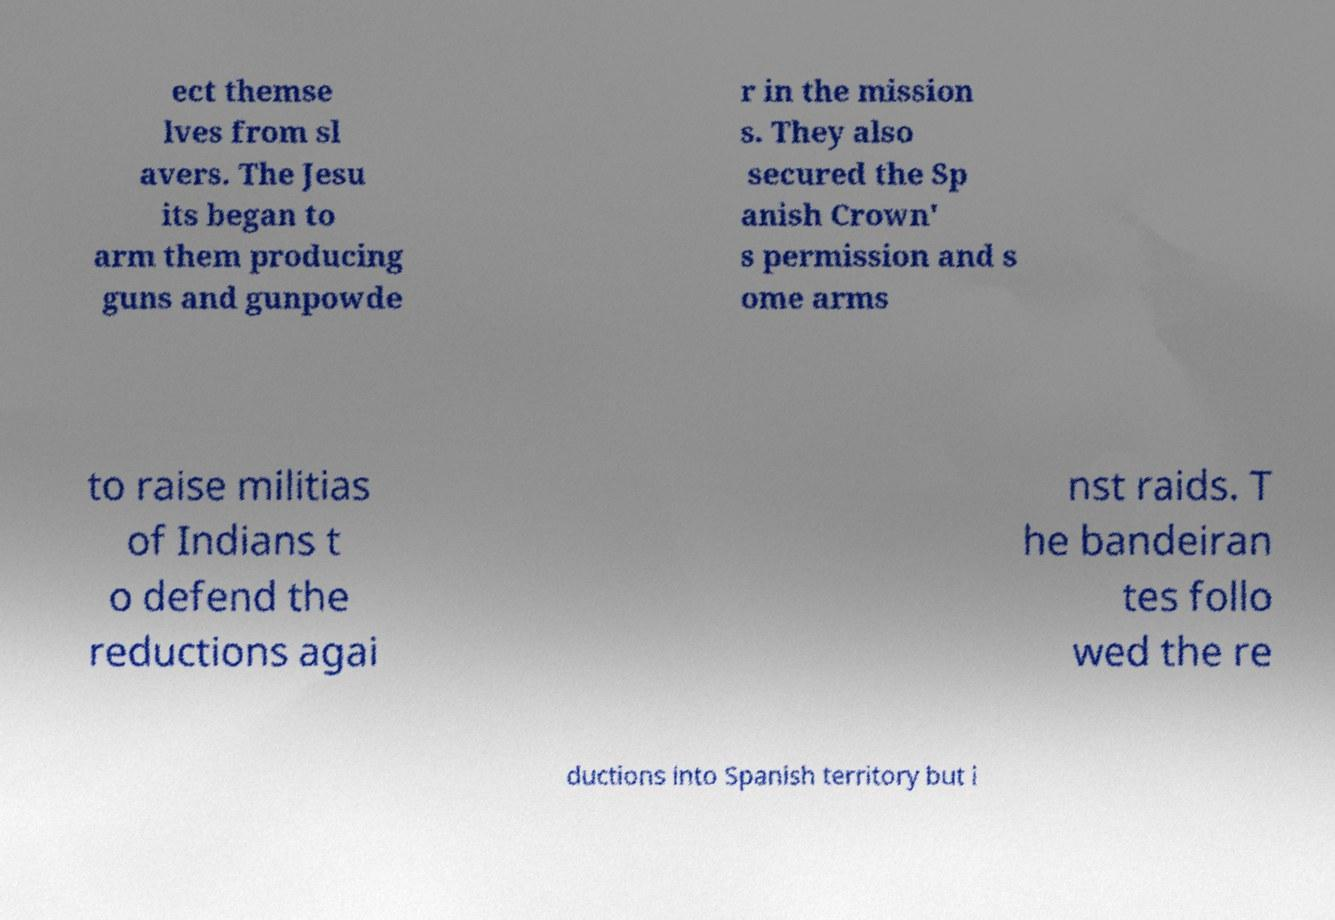For documentation purposes, I need the text within this image transcribed. Could you provide that? ect themse lves from sl avers. The Jesu its began to arm them producing guns and gunpowde r in the mission s. They also secured the Sp anish Crown' s permission and s ome arms to raise militias of Indians t o defend the reductions agai nst raids. T he bandeiran tes follo wed the re ductions into Spanish territory but i 